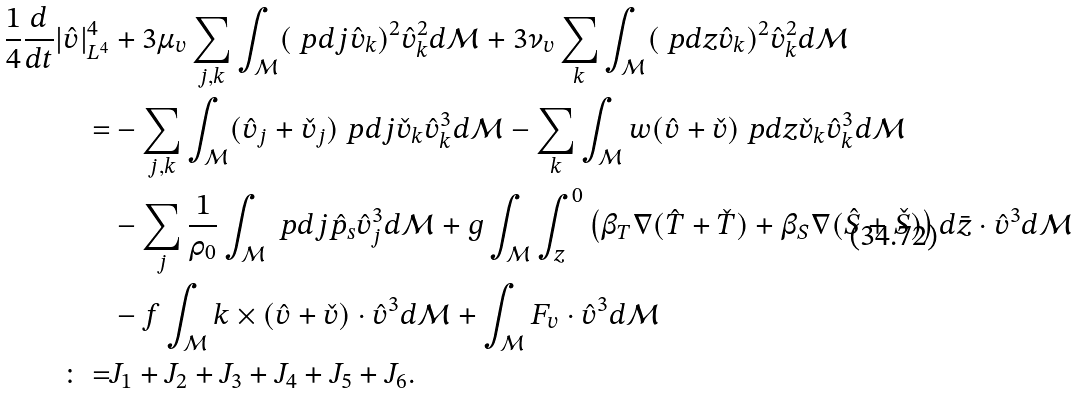<formula> <loc_0><loc_0><loc_500><loc_500>\frac { 1 } { 4 } \frac { d } { d t } | \hat { v } | ^ { 4 } _ { L ^ { 4 } } & + 3 \mu _ { v } \sum _ { j , k } \int _ { \mathcal { M } } ( \ p d { j } \hat { v } _ { k } ) ^ { 2 } \hat { v } _ { k } ^ { 2 } d \mathcal { M } + 3 \nu _ { v } \sum _ { k } \int _ { \mathcal { M } } ( \ p d { z } \hat { v } _ { k } ) ^ { 2 } \hat { v } _ { k } ^ { 2 } d \mathcal { M } \\ = & - \sum _ { j , k } \int _ { \mathcal { M } } ( \hat { v } _ { j } + \check { v } _ { j } ) \ p d { j } \check { v } _ { k } \hat { v } _ { k } ^ { 3 } d \mathcal { M } - \sum _ { k } \int _ { \mathcal { M } } w ( \hat { v } + \check { v } ) \ p d { z } \check { v } _ { k } \hat { v } _ { k } ^ { 3 } d \mathcal { M } \\ & - \sum _ { j } \frac { 1 } { \rho _ { 0 } } \int _ { \mathcal { M } } \ p d { j } \hat { p } _ { s } \hat { v } _ { j } ^ { 3 } d \mathcal { M } + g \int _ { \mathcal { M } } \int _ { z } ^ { 0 } \left ( \beta _ { T } \nabla ( \hat { T } + \check { T } ) + \beta _ { S } \nabla ( \hat { S } + \check { S } ) \right ) d \bar { z } \cdot \hat { v } ^ { 3 } d \mathcal { M } \\ & - f \int _ { \mathcal { M } } k \times ( \hat { v } + \check { v } ) \cdot \hat { v } ^ { 3 } d \mathcal { M } + \int _ { \mathcal { M } } F _ { v } \cdot \hat { v } ^ { 3 } d \mathcal { M } \\ \colon = & J _ { 1 } + J _ { 2 } + J _ { 3 } + J _ { 4 } + J _ { 5 } + J _ { 6 } .</formula> 